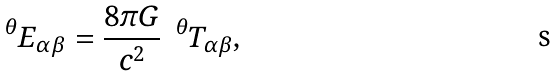Convert formula to latex. <formula><loc_0><loc_0><loc_500><loc_500>\quad ^ { \theta } E _ { \alpha \beta } = \frac { 8 \pi G } { c ^ { 2 } } \ \ ^ { \theta } T _ { \alpha \beta } ,</formula> 